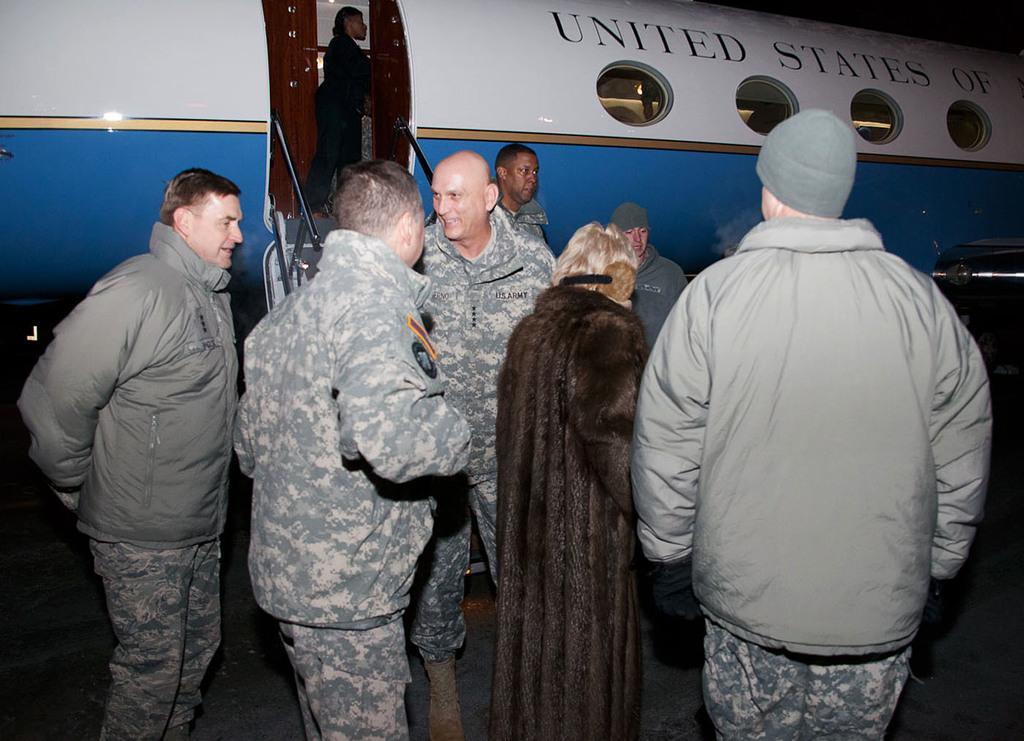Describe this image in one or two sentences. As we can see in the image there is a plane, stairs and few people here and there. The image is little dark. 